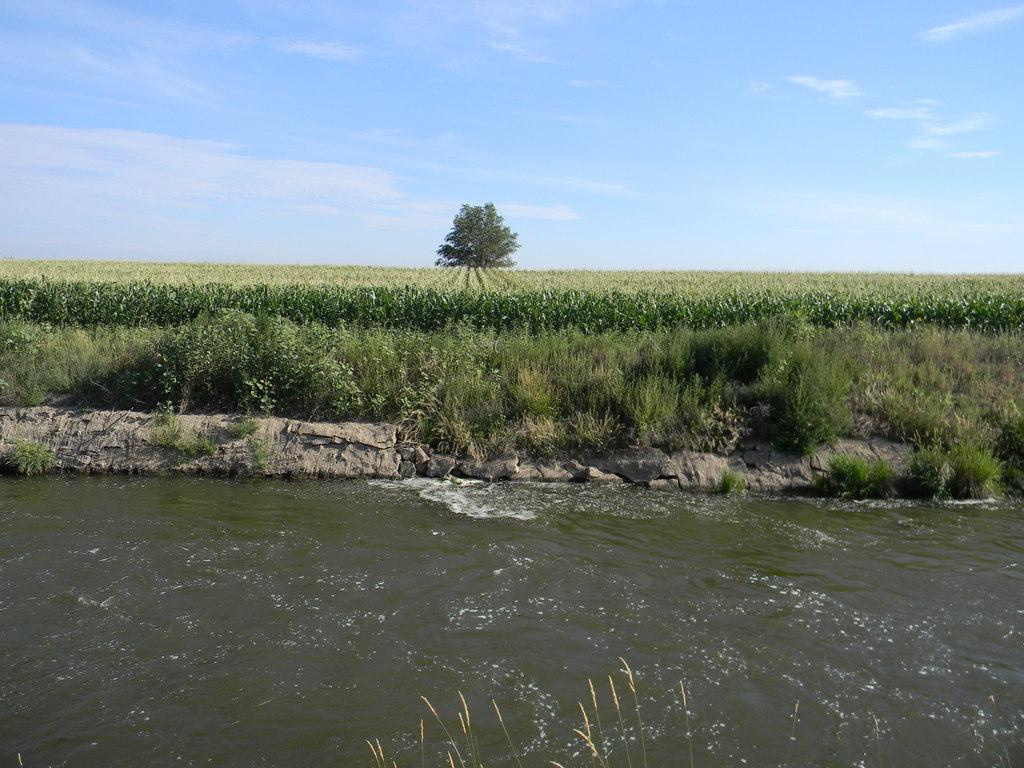What is present at the bottom of the image? There is water at the bottom of the image. What can be seen in the center of the image? There are crops and grass in the center of the image. What is located in the background of the image? There is a tree in the background of the image. What else is visible in the background of the image? The sky is visible in the background of the image. Where is the advertisement for the carriage service located in the image? There is no advertisement for a carriage service present in the image. What type of railway can be seen in the image? There is no railway present in the image. 